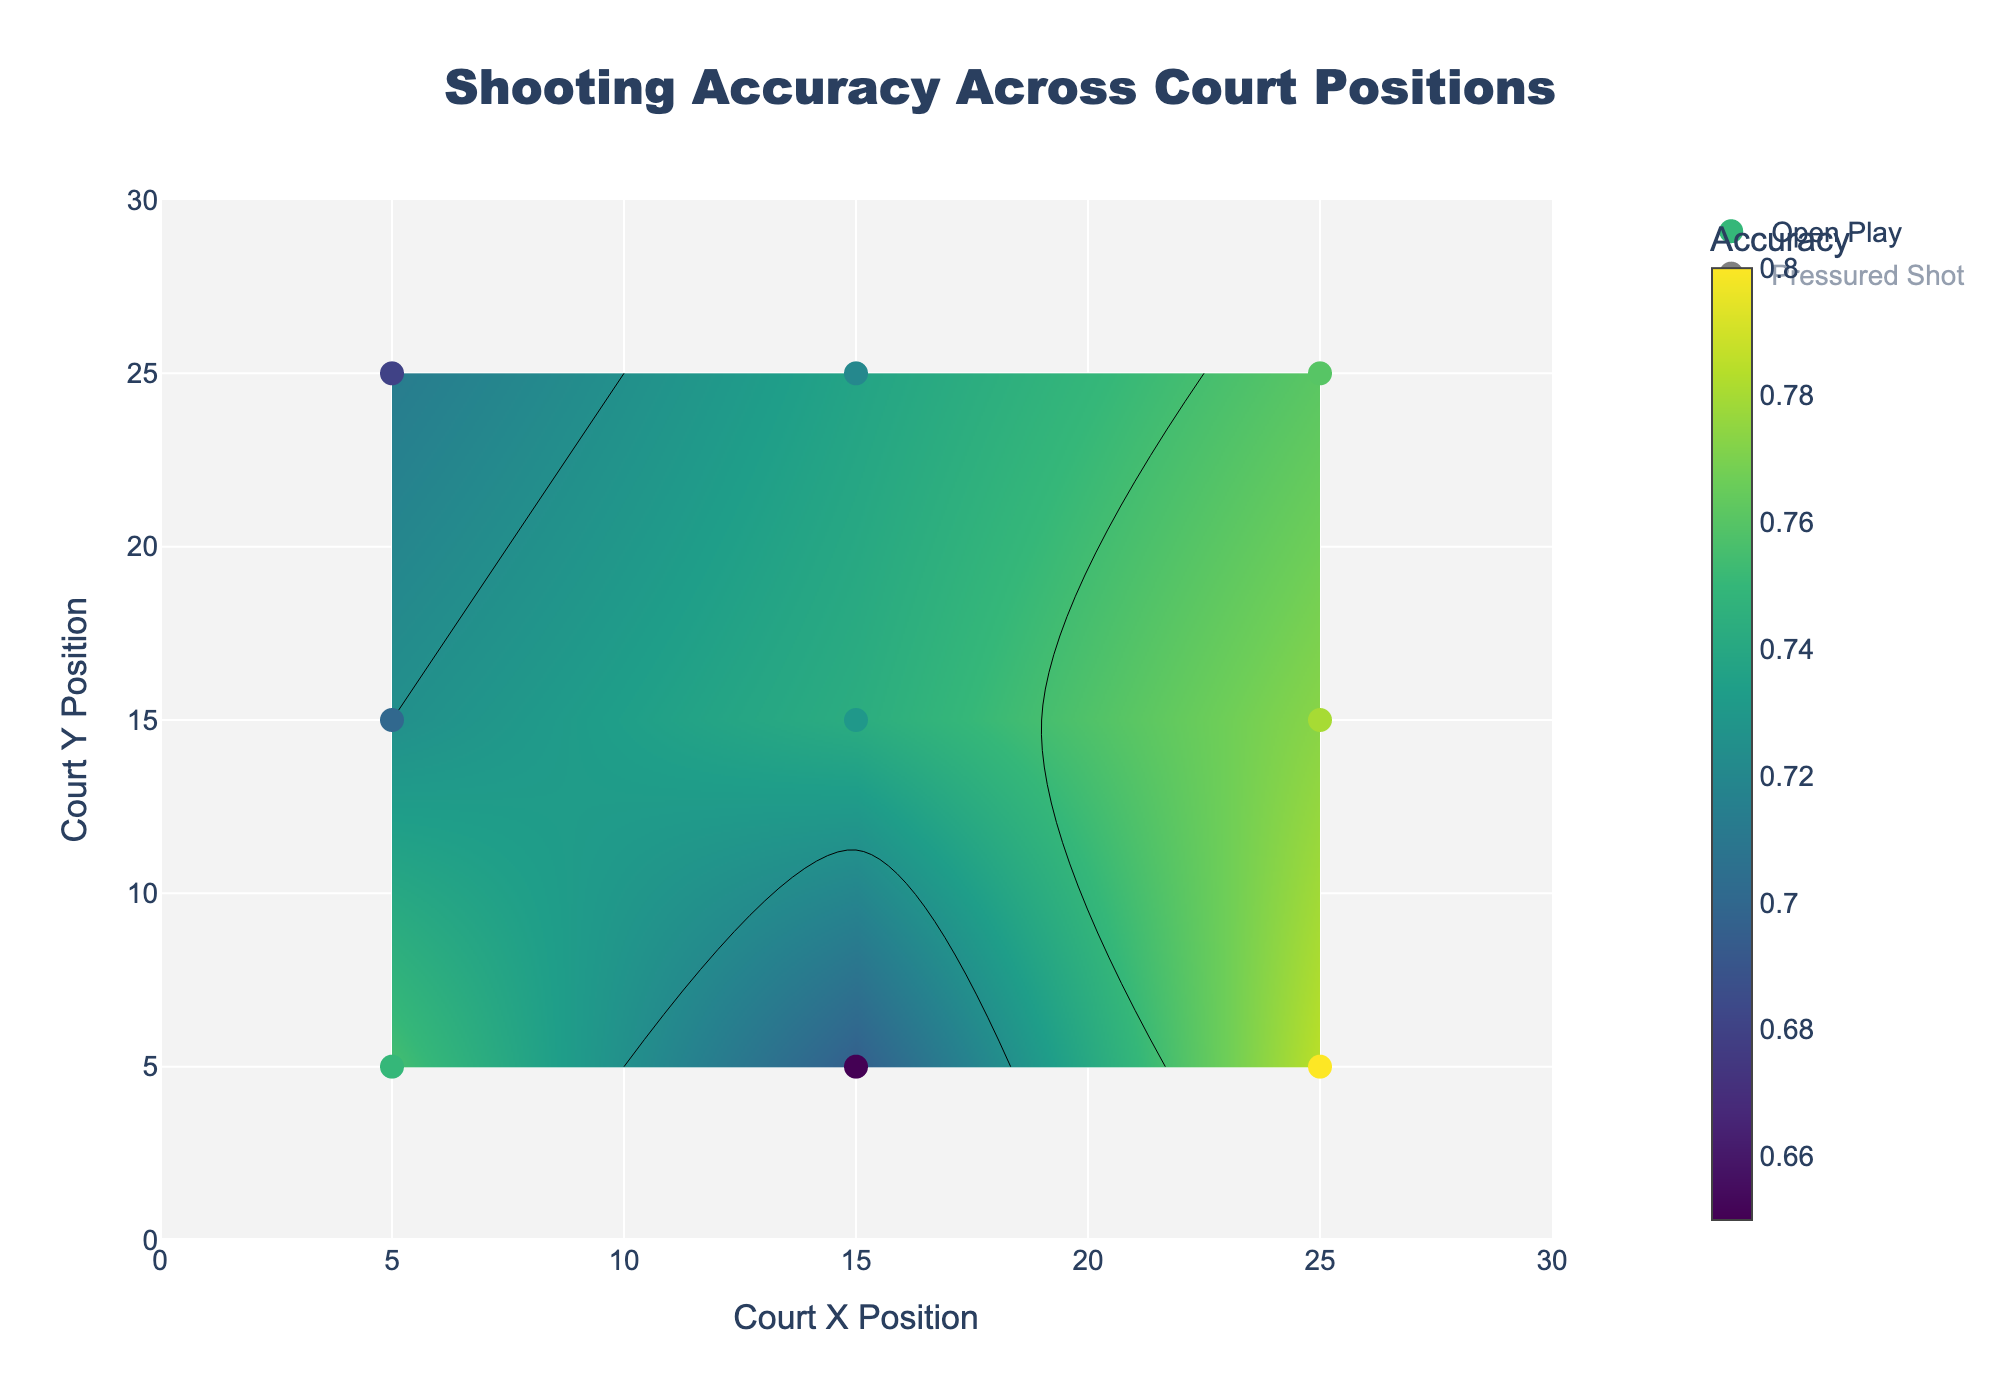What's the title of the figure? The title is written at the top of the figure in large, bold text. By looking at the figure, you can see the title listed there.
Answer: Shooting Accuracy Across Court Positions What are the axis labels? The labels for the x-axis and y-axis are typically found along the sides of the plot. By examining the figure, you can identify the labels for each axis.
Answer: Court X Position and Court Y Position How many unique shooting positions are there on the court? By counting the number of unique points shown on the scatter plot for all positions (both OpenPlay and PressuredShot), you can determine the total number of unique shooting positions.
Answer: 9 What is the accuracy range for Open Play shots? The accuracy range can be determined by examining the contours and the color bar for the Open Play shots, which are shown using the Viridis color scale. The start and end of the contour range define this.
Answer: 0.6 to 0.8 What's the average shooting accuracy for Pressured Shots at the position (15, 15)? To find this, locate the data point for Pressured Shots at (15, 15) and check its accuracy value, then sum these accuracies and divide by the number of data points, but for one point, it's just the accuracy itself.
Answer: 0.52 Compare the accuracy of Open Play shots at (5, 5) and (25, 5). Which is higher? By looking at Open Play data points at (5, 5) and (25, 5), you can compare their accuracies. The accuracy value at (25, 5) is higher than at (5, 5). Just check the accuracy values at these coordinates.
Answer: (25, 5) Which game situation has a higher average accuracy overall? To determine this, you need to compute the average accuracy for both Open Play and Pressured Shots. Sum all accuracy values for each situation and divide by the number of points for each.
Answer: Open Play Between which positions does the largest accuracy drop occur for Pressured Shots? To find the largest drop, compare the accuracy values of consecutive positions for Pressured Shots and identify the pair with the greatest difference.
Answer: (25, 5) to (15, 5) How does the color scheme differentiate between Open Play and Pressured Shots? By observing the contours and scatter plot markers, you can identify that Open Play uses the Viridis color scale while Pressured Shots use the Plasma color scale.
Answer: Viridis for Open Play, Plasma for Pressured Shots 